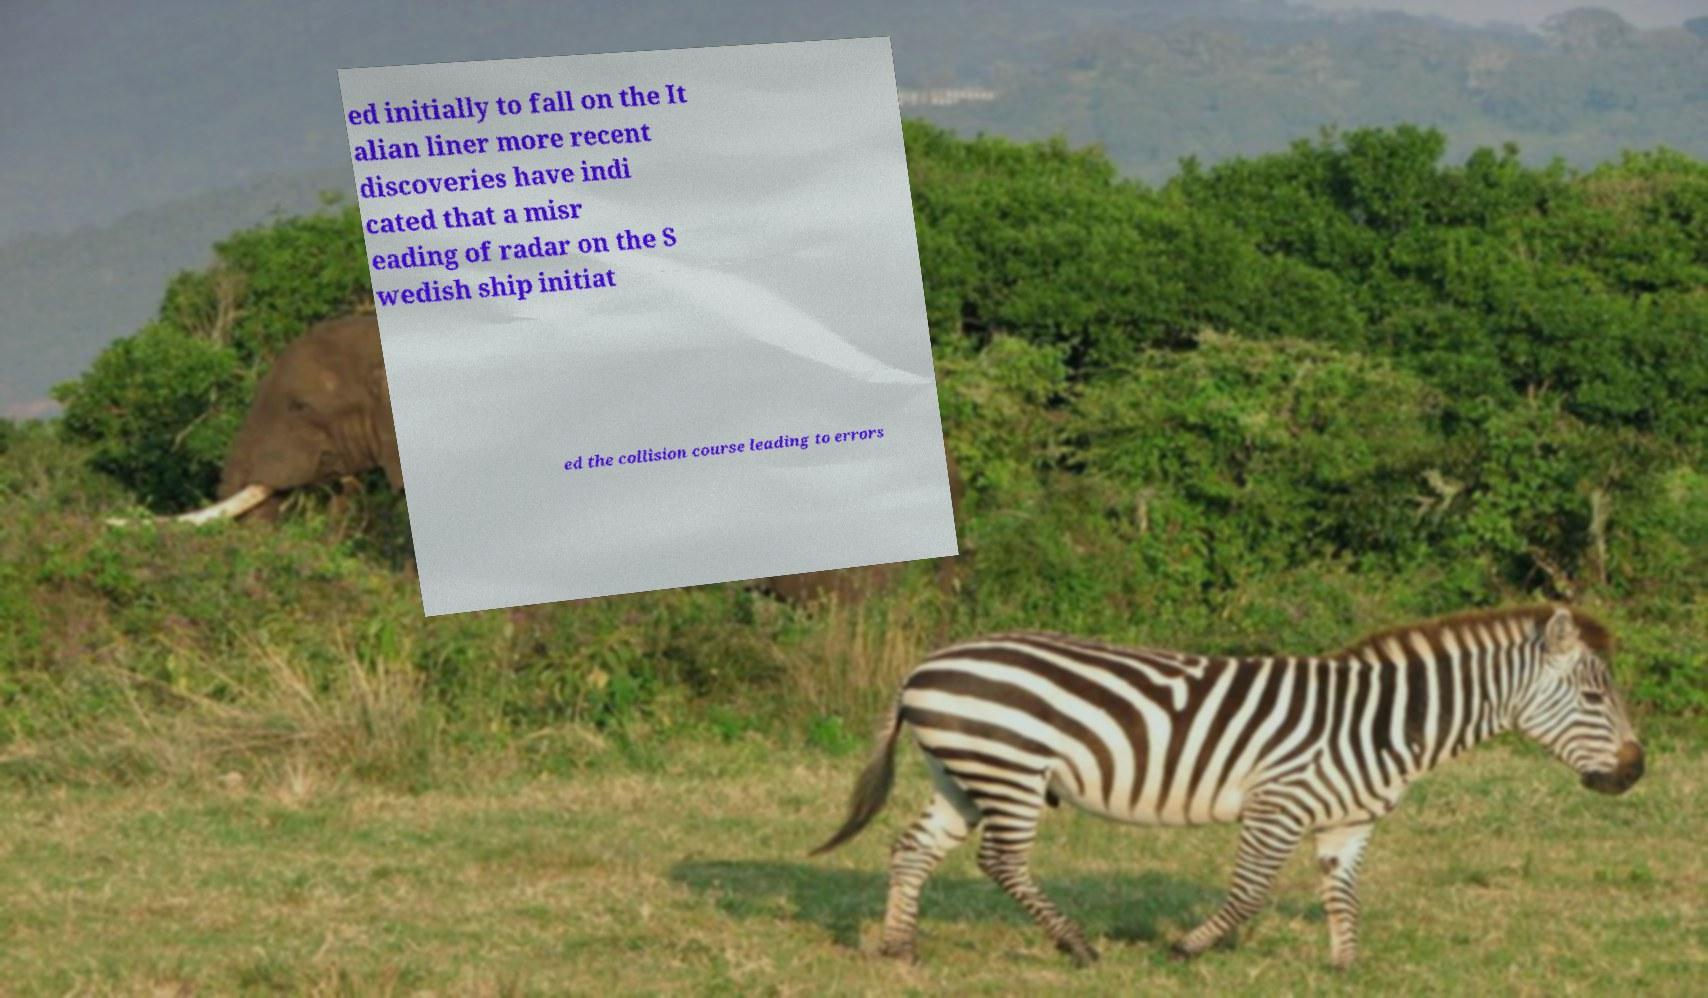Could you assist in decoding the text presented in this image and type it out clearly? ed initially to fall on the It alian liner more recent discoveries have indi cated that a misr eading of radar on the S wedish ship initiat ed the collision course leading to errors 